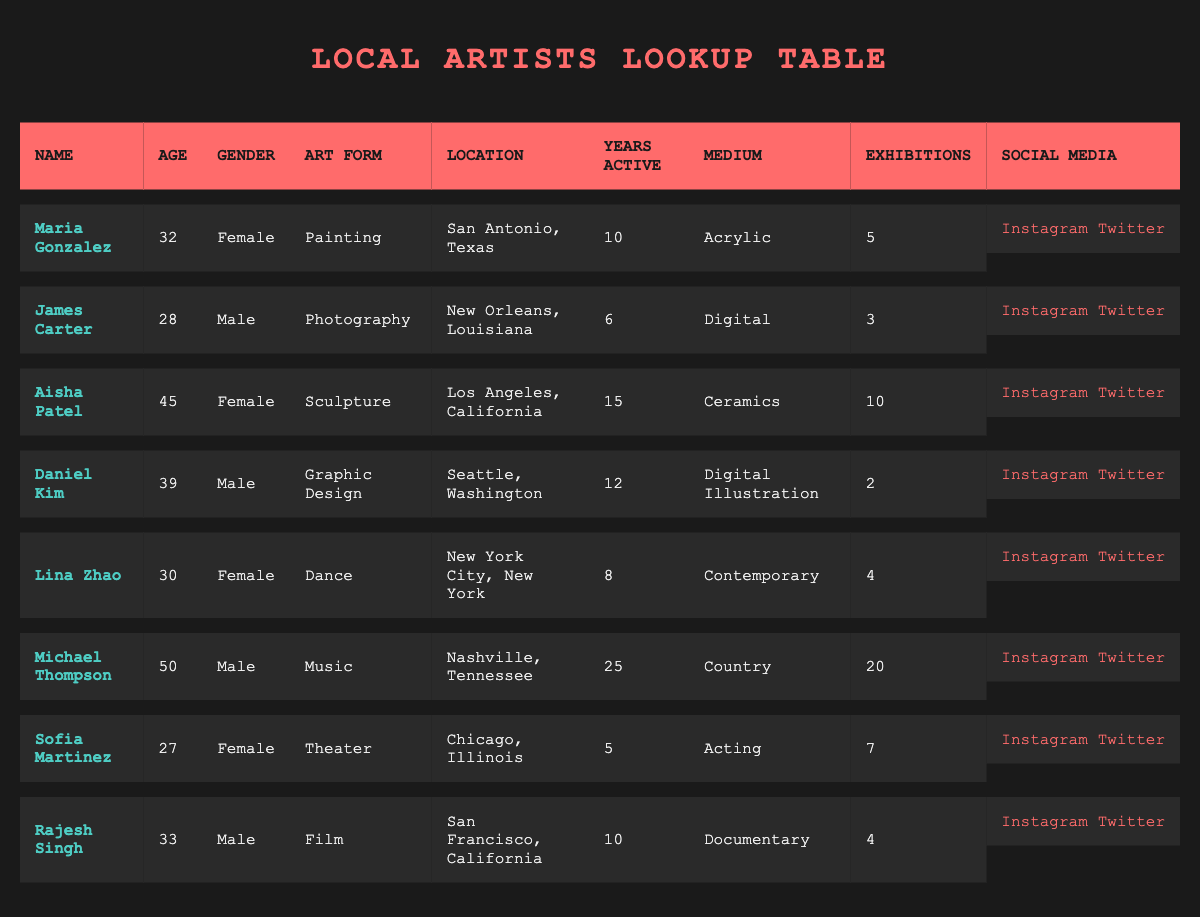What is the art form of Maria Gonzalez? Maria Gonzalez's entry in the table lists her art form as "Painting."
Answer: Painting Which artist has been active the longest? Michael Thompson has been active for 25 years, which is the highest number in the "Years Active" column among all artists listed.
Answer: Michael Thompson Is Aisha Patel's medium Ceramics? Aisha Patel's entry states that her medium is Ceramics, which confirms the fact.
Answer: Yes What is the total number of exhibitions held by artists located in San Francisco, California? Rajesh Singh is the only artist from San Francisco, and his exhibitions total 4. Since he is the only one contributing to this total, the answer is directly from his entry.
Answer: 4 What is the average age of female artists in the table? The ages of the female artists are 32 (Maria Gonzalez), 45 (Aisha Patel), 30 (Lina Zhao), and 27 (Sofia Martinez). Adding these together gives 32 + 45 + 30 + 27 = 134. There are 4 female artists, so the average age is 134 / 4 = 33.5.
Answer: 33.5 Which artist located in Chicago, Illinois has the most exhibitions? Sofia Martinez, who is from Chicago, has 7 exhibitions, which is currently the highest among the artists listed from that location, as she is the only one from Chicago in the data.
Answer: 7 Do any male artists specialize in Dance? Reviewing the "Art Form" column, we find that no male artists are listed as specializing in Dance, making the answer clear.
Answer: No How many more years of experience does Michael Thompson have compared to James Carter? Michael Thompson has 25 years of experience while James Carter has 6 years. The difference is 25 - 6 = 19 years.
Answer: 19 years Which location has the largest number of active artists? By comparing the locations and counting unique entries, both San Francisco (Rajesh Singh) and Los Angeles (Aisha Patel) have unique artists. However, active artists are represented directly. Therefore, for broader analysis, both are 1 and do not have a predominant location by number above the others compared.
Answer: No single predominant location 